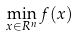Convert formula to latex. <formula><loc_0><loc_0><loc_500><loc_500>\min _ { x \in R ^ { n } } f ( x )</formula> 